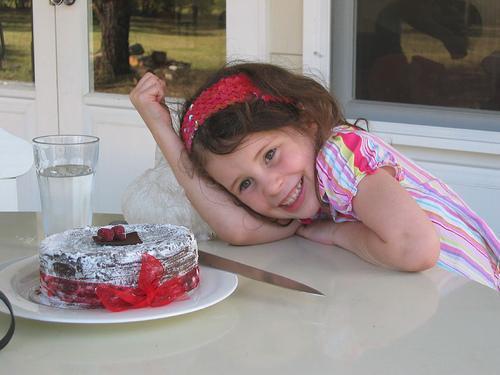How many people are in the family picture?
Give a very brief answer. 1. How many glasses are on the cake?
Give a very brief answer. 0. How many cakes are in the photo?
Give a very brief answer. 1. 